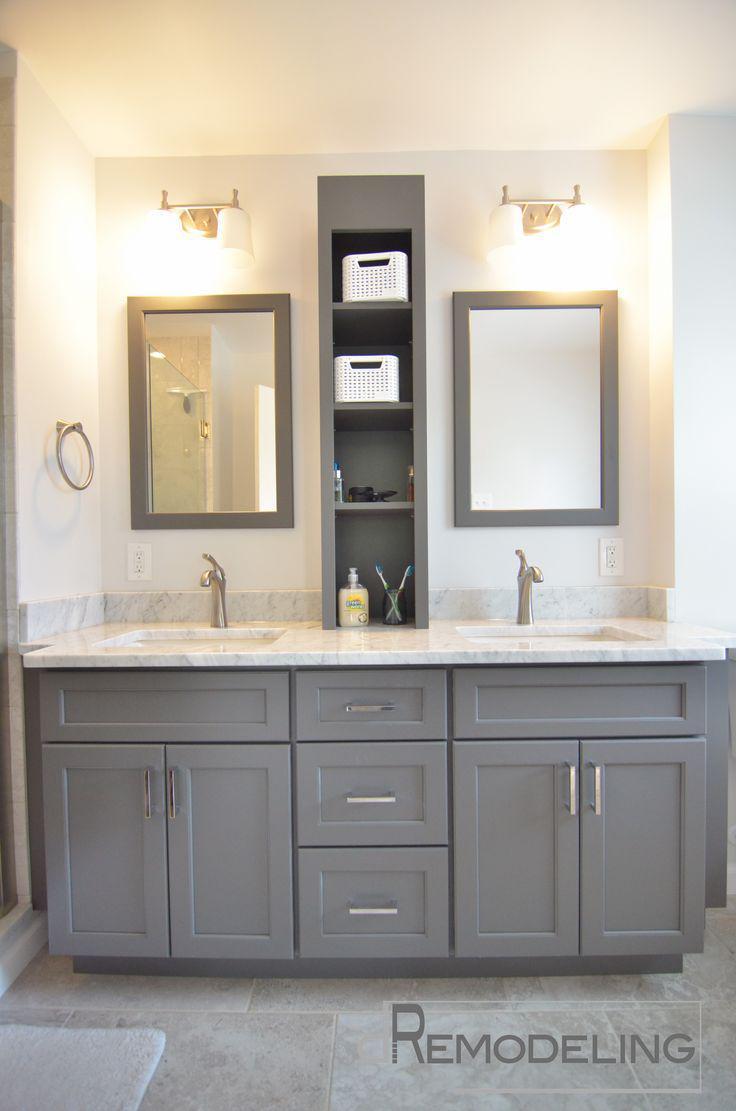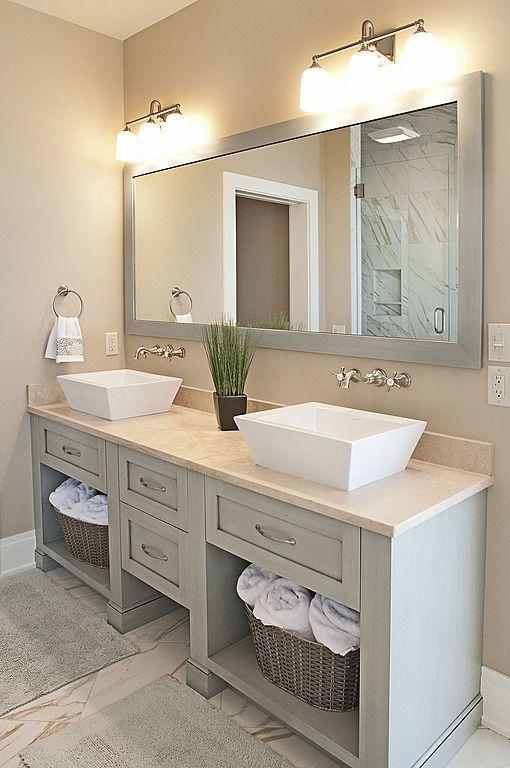The first image is the image on the left, the second image is the image on the right. Examine the images to the left and right. Is the description "A bathroom includes two oval shapes on the wall flanking a white cabinet, with lights above the ovals." accurate? Answer yes or no. No. The first image is the image on the left, the second image is the image on the right. For the images displayed, is the sentence "There is a single mirror over the counter in the image on the right." factually correct? Answer yes or no. Yes. The first image is the image on the left, the second image is the image on the right. Given the left and right images, does the statement "The right image has two round mirrors on the wall above a bathroom sink." hold true? Answer yes or no. No. 